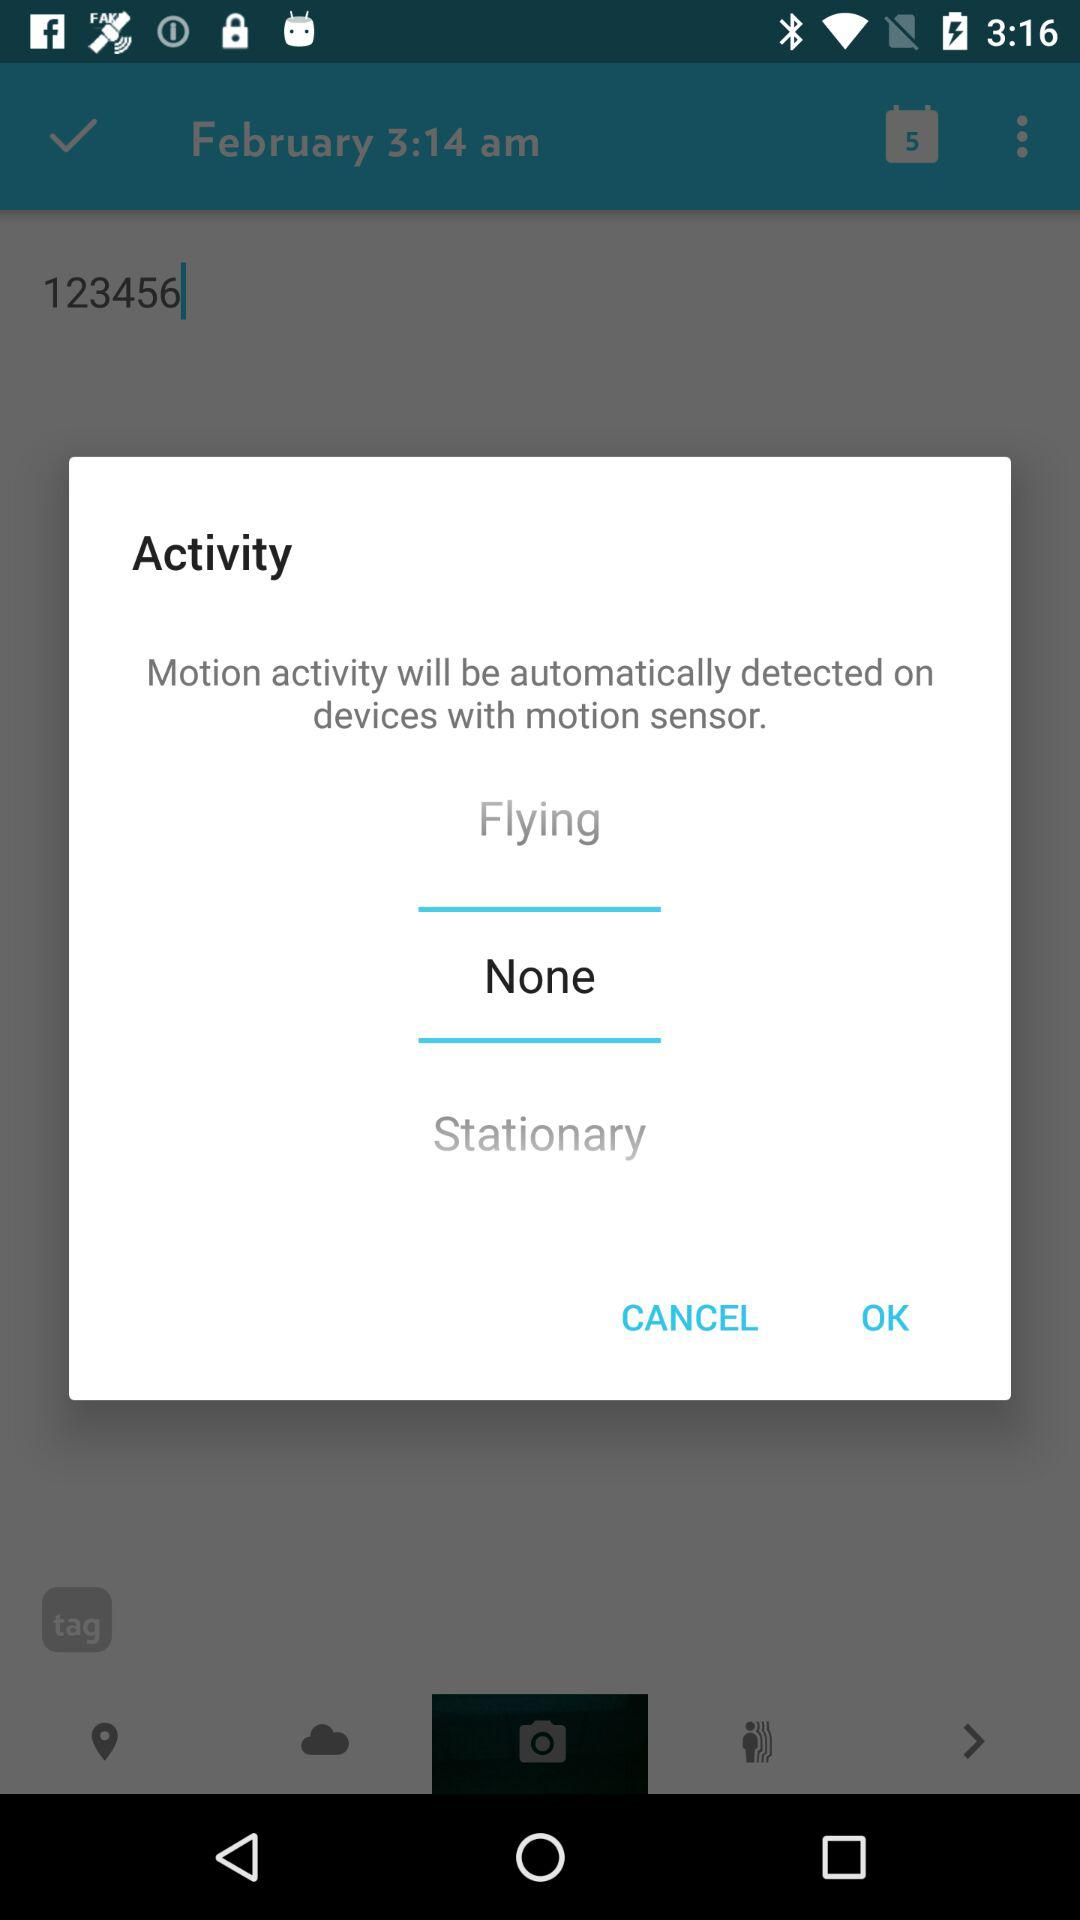What activity has been selected? The selected activity is "None". 